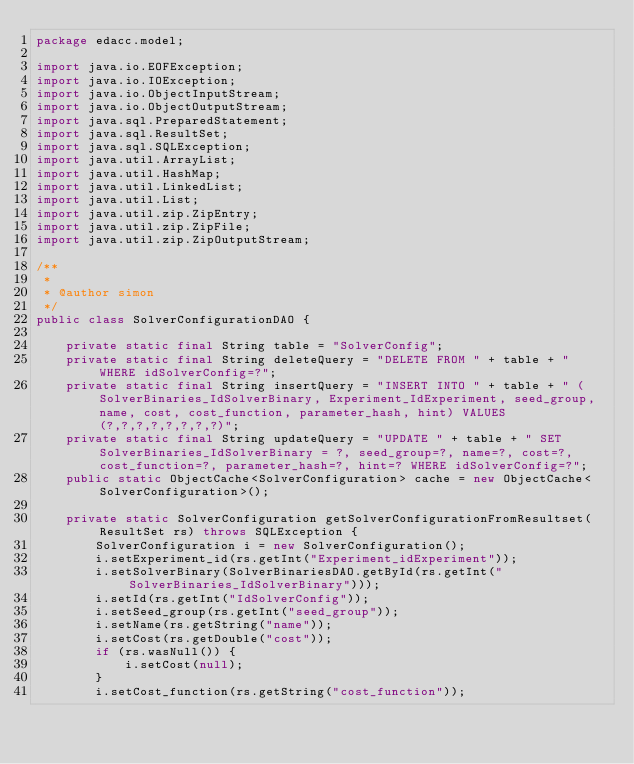<code> <loc_0><loc_0><loc_500><loc_500><_Java_>package edacc.model;

import java.io.EOFException;
import java.io.IOException;
import java.io.ObjectInputStream;
import java.io.ObjectOutputStream;
import java.sql.PreparedStatement;
import java.sql.ResultSet;
import java.sql.SQLException;
import java.util.ArrayList;
import java.util.HashMap;
import java.util.LinkedList;
import java.util.List;
import java.util.zip.ZipEntry;
import java.util.zip.ZipFile;
import java.util.zip.ZipOutputStream;

/**
 *
 * @author simon
 */
public class SolverConfigurationDAO {

    private static final String table = "SolverConfig";
    private static final String deleteQuery = "DELETE FROM " + table + " WHERE idSolverConfig=?";
    private static final String insertQuery = "INSERT INTO " + table + " (SolverBinaries_IdSolverBinary, Experiment_IdExperiment, seed_group, name, cost, cost_function, parameter_hash, hint) VALUES (?,?,?,?,?,?,?,?)";
    private static final String updateQuery = "UPDATE " + table + " SET SolverBinaries_IdSolverBinary = ?, seed_group=?, name=?, cost=?, cost_function=?, parameter_hash=?, hint=? WHERE idSolverConfig=?";
    public static ObjectCache<SolverConfiguration> cache = new ObjectCache<SolverConfiguration>();

    private static SolverConfiguration getSolverConfigurationFromResultset(ResultSet rs) throws SQLException {
        SolverConfiguration i = new SolverConfiguration();
        i.setExperiment_id(rs.getInt("Experiment_idExperiment"));
        i.setSolverBinary(SolverBinariesDAO.getById(rs.getInt("SolverBinaries_IdSolverBinary")));
        i.setId(rs.getInt("IdSolverConfig"));
        i.setSeed_group(rs.getInt("seed_group"));
        i.setName(rs.getString("name"));
        i.setCost(rs.getDouble("cost"));
        if (rs.wasNull()) {
            i.setCost(null);
        }
        i.setCost_function(rs.getString("cost_function"));</code> 